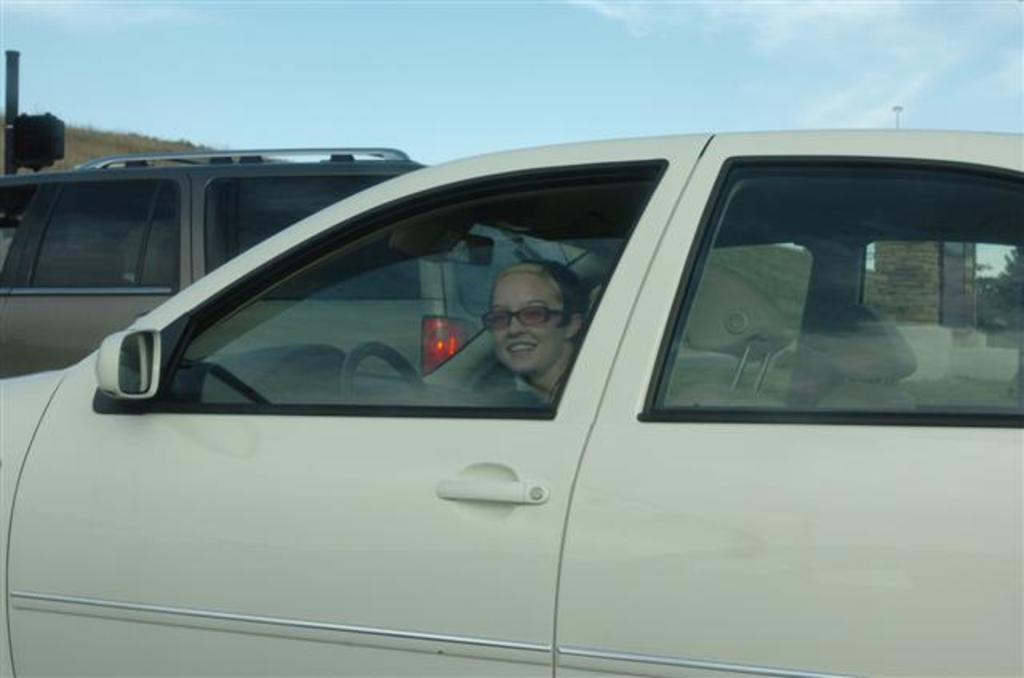Describe this image in one or two sentences. In this image I can see few vehicles. In front the vehicle is in white color and I can also see few people sitting in the vehicle, background I can see trees in green color and the sky is in blue color. 